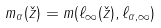<formula> <loc_0><loc_0><loc_500><loc_500>m _ { \alpha } ( \check { z } ) = m ( \ell _ { \infty } ( \check { z } ) , \ell _ { \alpha , \infty } )</formula> 